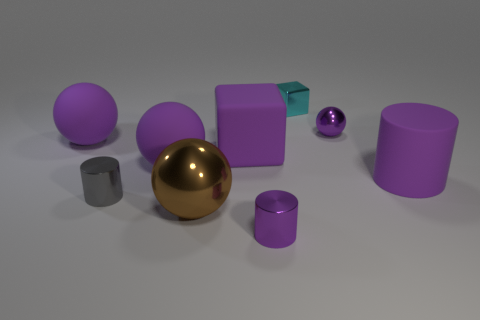There is a big thing that is right of the cyan shiny thing; does it have the same color as the big rubber cube that is in front of the cyan thing?
Your answer should be very brief. Yes. Does the small purple metal thing that is right of the cyan cube have the same shape as the small purple metallic object that is in front of the large brown ball?
Offer a terse response. No. There is a block on the left side of the small cyan shiny object; what material is it?
Give a very brief answer. Rubber. There is a block that is the same color as the big cylinder; what is its size?
Ensure brevity in your answer.  Large. How many things are either metallic spheres that are on the right side of the large metal thing or brown objects?
Make the answer very short. 2. Is the number of big brown shiny things that are to the right of the small cyan shiny block the same as the number of large blocks?
Provide a succinct answer. No. Is the purple block the same size as the brown ball?
Provide a succinct answer. Yes. The ball that is the same size as the cyan thing is what color?
Make the answer very short. Purple. There is a brown thing; is it the same size as the purple cylinder behind the brown metallic thing?
Keep it short and to the point. Yes. What number of cylinders have the same color as the large cube?
Provide a short and direct response. 2. 